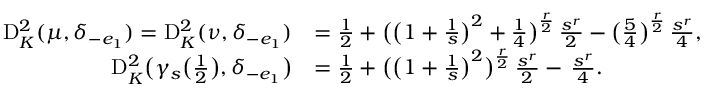Convert formula to latex. <formula><loc_0><loc_0><loc_500><loc_500>\begin{array} { r l } { \mathrm D _ { K } ^ { 2 } ( \mu , \delta _ { - e _ { 1 } } ) = \mathrm D _ { K } ^ { 2 } ( \nu , \delta _ { - e _ { 1 } } ) } & { = \frac { 1 } { 2 } + \left ( \left ( 1 + \frac { 1 } { s } \right ) ^ { 2 } + \frac { 1 } { 4 } \right ) ^ { \frac { r } { 2 } } \, \frac { s ^ { r } } { 2 } - \left ( \frac { 5 } { 4 } \right ) ^ { \frac { r } { 2 } } \, \frac { s ^ { r } } { 4 } , } \\ { \mathrm D _ { K } ^ { 2 } \left ( \gamma _ { s } \left ( \frac { 1 } { 2 } \right ) , \delta _ { - e _ { 1 } } \right ) } & { = \frac { 1 } { 2 } + \left ( \left ( 1 + \frac { 1 } { s } \right ) ^ { 2 } \right ) ^ { \frac { r } { 2 } } \, \frac { s ^ { r } } { 2 } - \, \frac { s ^ { r } } { 4 } . } \end{array}</formula> 